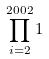<formula> <loc_0><loc_0><loc_500><loc_500>\prod _ { i = 2 } ^ { 2 0 0 2 } 1</formula> 